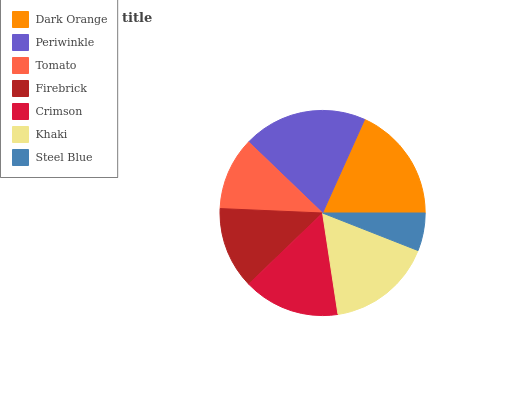Is Steel Blue the minimum?
Answer yes or no. Yes. Is Periwinkle the maximum?
Answer yes or no. Yes. Is Tomato the minimum?
Answer yes or no. No. Is Tomato the maximum?
Answer yes or no. No. Is Periwinkle greater than Tomato?
Answer yes or no. Yes. Is Tomato less than Periwinkle?
Answer yes or no. Yes. Is Tomato greater than Periwinkle?
Answer yes or no. No. Is Periwinkle less than Tomato?
Answer yes or no. No. Is Crimson the high median?
Answer yes or no. Yes. Is Crimson the low median?
Answer yes or no. Yes. Is Tomato the high median?
Answer yes or no. No. Is Tomato the low median?
Answer yes or no. No. 